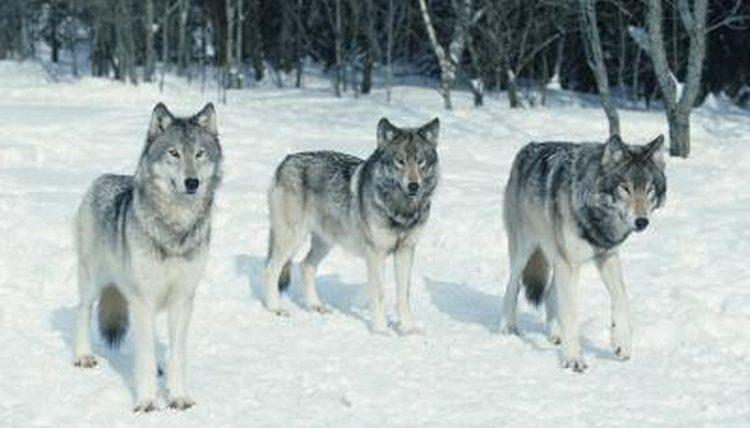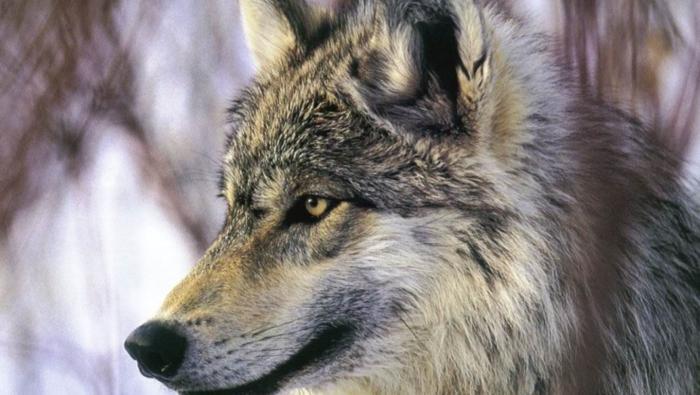The first image is the image on the left, the second image is the image on the right. Considering the images on both sides, is "Only the head of the animal is visible in the image on the left." valid? Answer yes or no. No. 